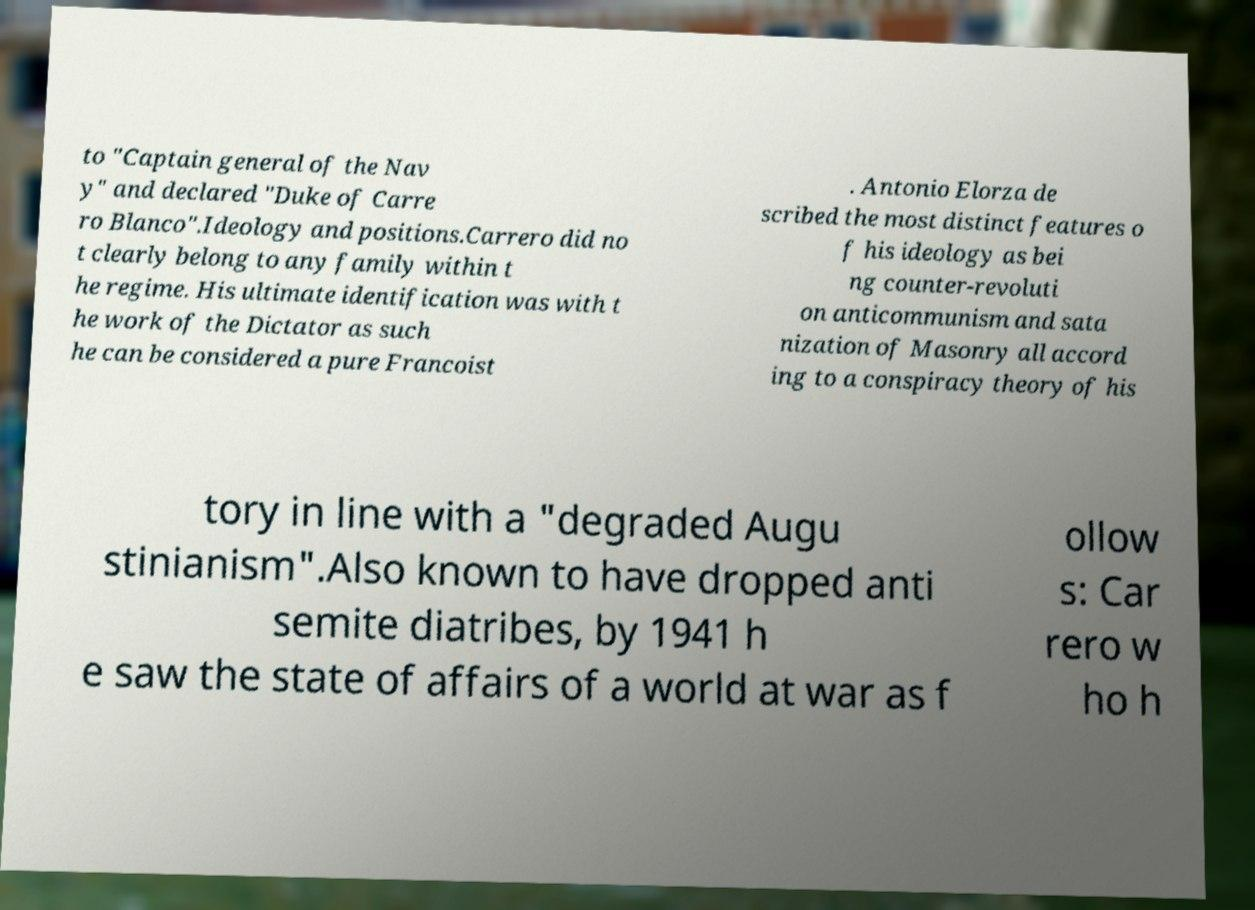Could you extract and type out the text from this image? to "Captain general of the Nav y" and declared "Duke of Carre ro Blanco".Ideology and positions.Carrero did no t clearly belong to any family within t he regime. His ultimate identification was with t he work of the Dictator as such he can be considered a pure Francoist . Antonio Elorza de scribed the most distinct features o f his ideology as bei ng counter-revoluti on anticommunism and sata nization of Masonry all accord ing to a conspiracy theory of his tory in line with a "degraded Augu stinianism".Also known to have dropped anti semite diatribes, by 1941 h e saw the state of affairs of a world at war as f ollow s: Car rero w ho h 